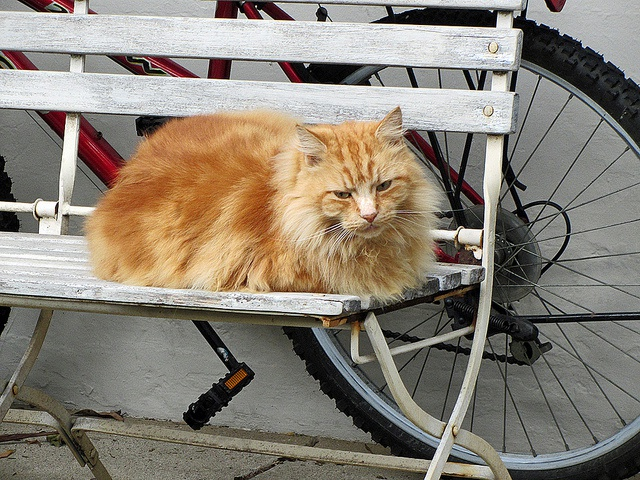Describe the objects in this image and their specific colors. I can see bench in gray, lightgray, tan, and darkgray tones, bicycle in gray, black, darkgray, and maroon tones, and cat in gray, tan, and red tones in this image. 